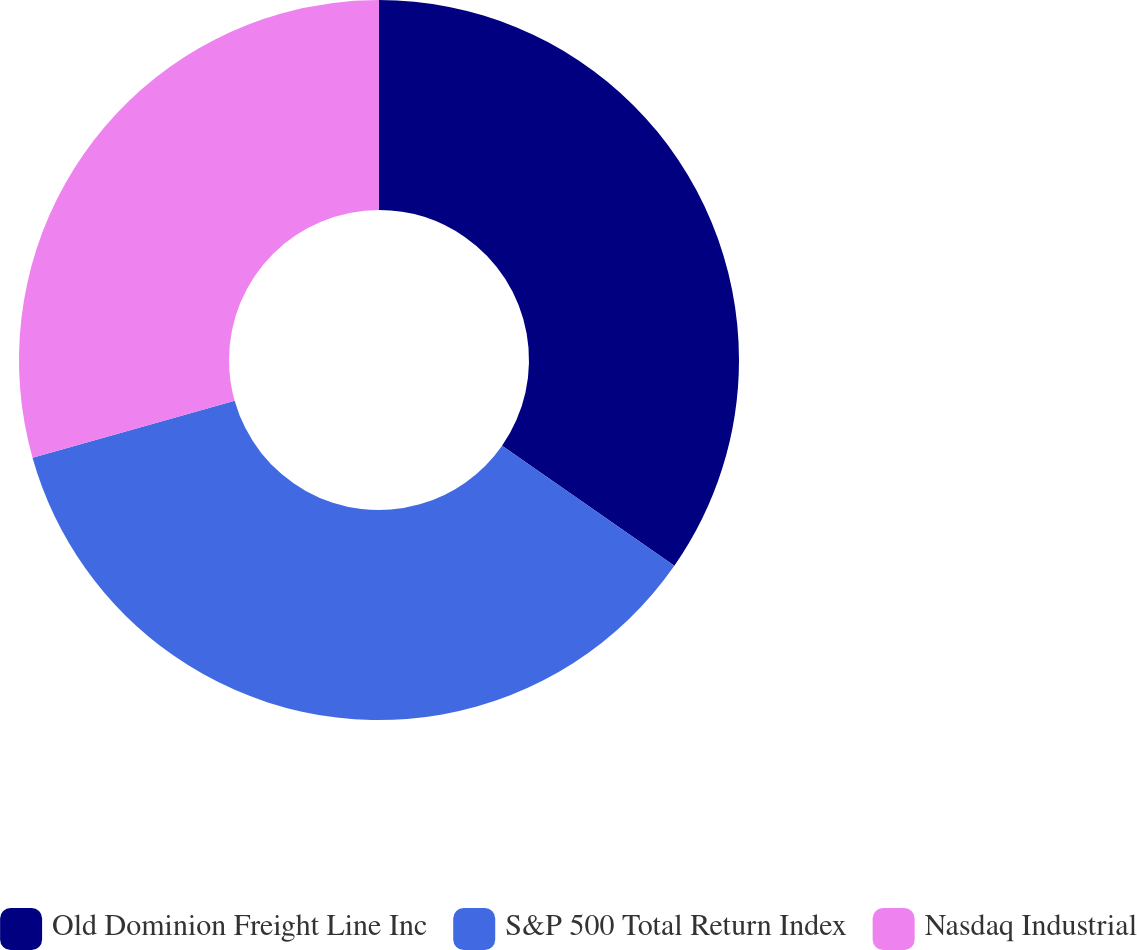Convert chart to OTSL. <chart><loc_0><loc_0><loc_500><loc_500><pie_chart><fcel>Old Dominion Freight Line Inc<fcel>S&P 500 Total Return Index<fcel>Nasdaq Industrial<nl><fcel>34.69%<fcel>35.94%<fcel>29.38%<nl></chart> 